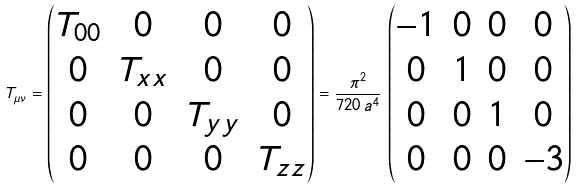Convert formula to latex. <formula><loc_0><loc_0><loc_500><loc_500>T _ { \mu \nu } = \begin{pmatrix} T _ { 0 0 } & 0 & 0 & 0 \\ 0 & T _ { x x } & 0 & 0 \\ 0 & 0 & T _ { y y } & 0 \\ 0 & 0 & 0 & T _ { z z } \end{pmatrix} = \frac { \pi ^ { 2 } } { 7 2 0 \, a ^ { 4 } } \, \begin{pmatrix} - 1 & 0 & 0 & 0 \\ 0 & 1 & 0 & 0 \\ 0 & 0 & 1 & 0 \\ 0 & 0 & 0 & - 3 \end{pmatrix}</formula> 